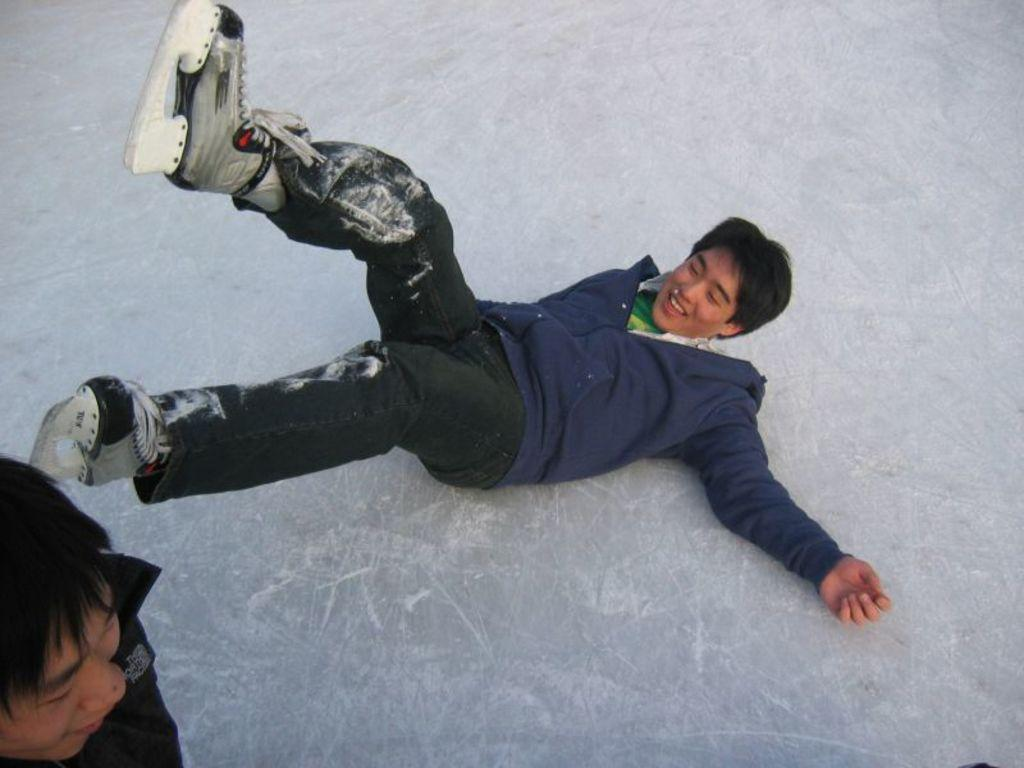What is the position of the person in the image? There is a person lying on the floor in the image. Can you describe the other person in the image? There is another person standing in the image. What is the surface on which the people are situated? The floor is covered in snow. What type of quartz can be seen in the image? There is no quartz present in the image. How does the snow in the image expand? The snow in the image is not shown expanding; it is depicted as a static surface. 